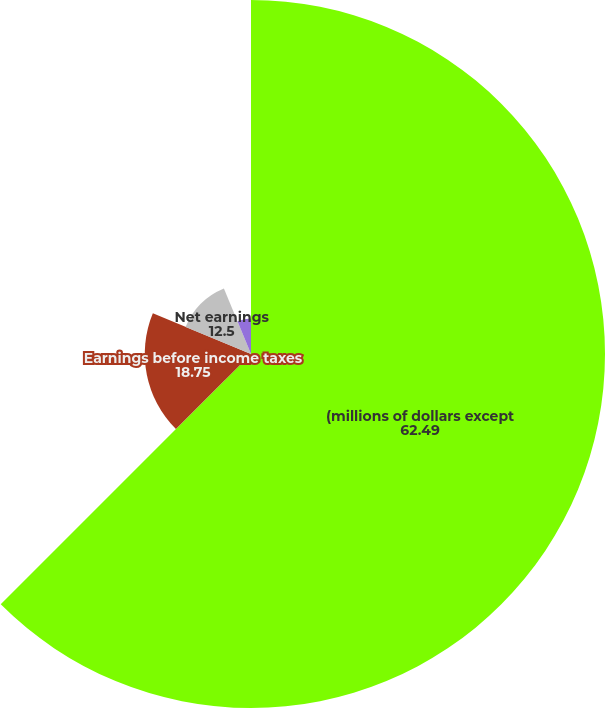Convert chart to OTSL. <chart><loc_0><loc_0><loc_500><loc_500><pie_chart><fcel>(millions of dollars except<fcel>Earnings before income taxes<fcel>Net earnings<fcel>Earnings per share - basic<fcel>Earnings per share - diluted<nl><fcel>62.49%<fcel>18.75%<fcel>12.5%<fcel>0.0%<fcel>6.25%<nl></chart> 